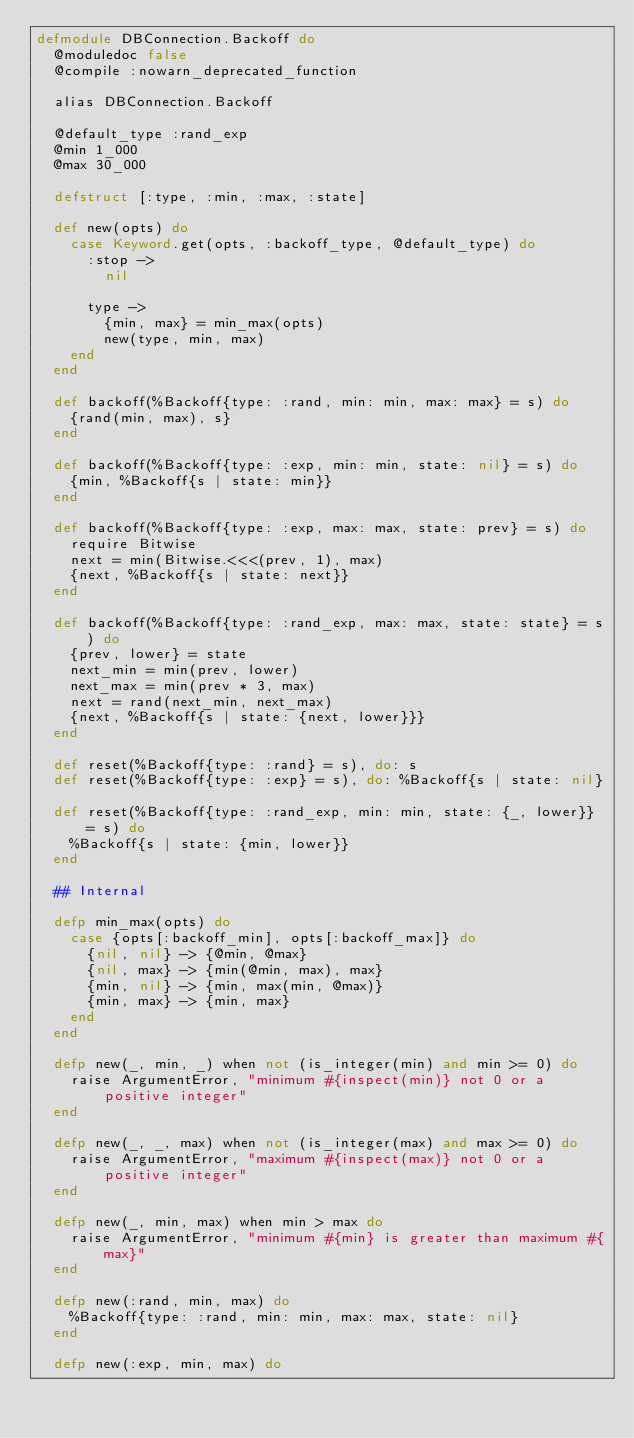<code> <loc_0><loc_0><loc_500><loc_500><_Elixir_>defmodule DBConnection.Backoff do
  @moduledoc false
  @compile :nowarn_deprecated_function

  alias DBConnection.Backoff

  @default_type :rand_exp
  @min 1_000
  @max 30_000

  defstruct [:type, :min, :max, :state]

  def new(opts) do
    case Keyword.get(opts, :backoff_type, @default_type) do
      :stop ->
        nil

      type ->
        {min, max} = min_max(opts)
        new(type, min, max)
    end
  end

  def backoff(%Backoff{type: :rand, min: min, max: max} = s) do
    {rand(min, max), s}
  end

  def backoff(%Backoff{type: :exp, min: min, state: nil} = s) do
    {min, %Backoff{s | state: min}}
  end

  def backoff(%Backoff{type: :exp, max: max, state: prev} = s) do
    require Bitwise
    next = min(Bitwise.<<<(prev, 1), max)
    {next, %Backoff{s | state: next}}
  end

  def backoff(%Backoff{type: :rand_exp, max: max, state: state} = s) do
    {prev, lower} = state
    next_min = min(prev, lower)
    next_max = min(prev * 3, max)
    next = rand(next_min, next_max)
    {next, %Backoff{s | state: {next, lower}}}
  end

  def reset(%Backoff{type: :rand} = s), do: s
  def reset(%Backoff{type: :exp} = s), do: %Backoff{s | state: nil}

  def reset(%Backoff{type: :rand_exp, min: min, state: {_, lower}} = s) do
    %Backoff{s | state: {min, lower}}
  end

  ## Internal

  defp min_max(opts) do
    case {opts[:backoff_min], opts[:backoff_max]} do
      {nil, nil} -> {@min, @max}
      {nil, max} -> {min(@min, max), max}
      {min, nil} -> {min, max(min, @max)}
      {min, max} -> {min, max}
    end
  end

  defp new(_, min, _) when not (is_integer(min) and min >= 0) do
    raise ArgumentError, "minimum #{inspect(min)} not 0 or a positive integer"
  end

  defp new(_, _, max) when not (is_integer(max) and max >= 0) do
    raise ArgumentError, "maximum #{inspect(max)} not 0 or a positive integer"
  end

  defp new(_, min, max) when min > max do
    raise ArgumentError, "minimum #{min} is greater than maximum #{max}"
  end

  defp new(:rand, min, max) do
    %Backoff{type: :rand, min: min, max: max, state: nil}
  end

  defp new(:exp, min, max) do</code> 